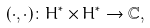Convert formula to latex. <formula><loc_0><loc_0><loc_500><loc_500>( \cdot , \cdot ) \colon H ^ { * } \times H ^ { * } \rightarrow \mathbb { C } ,</formula> 